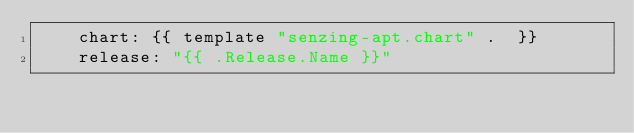<code> <loc_0><loc_0><loc_500><loc_500><_YAML_>    chart: {{ template "senzing-apt.chart" .  }}
    release: "{{ .Release.Name }}"</code> 